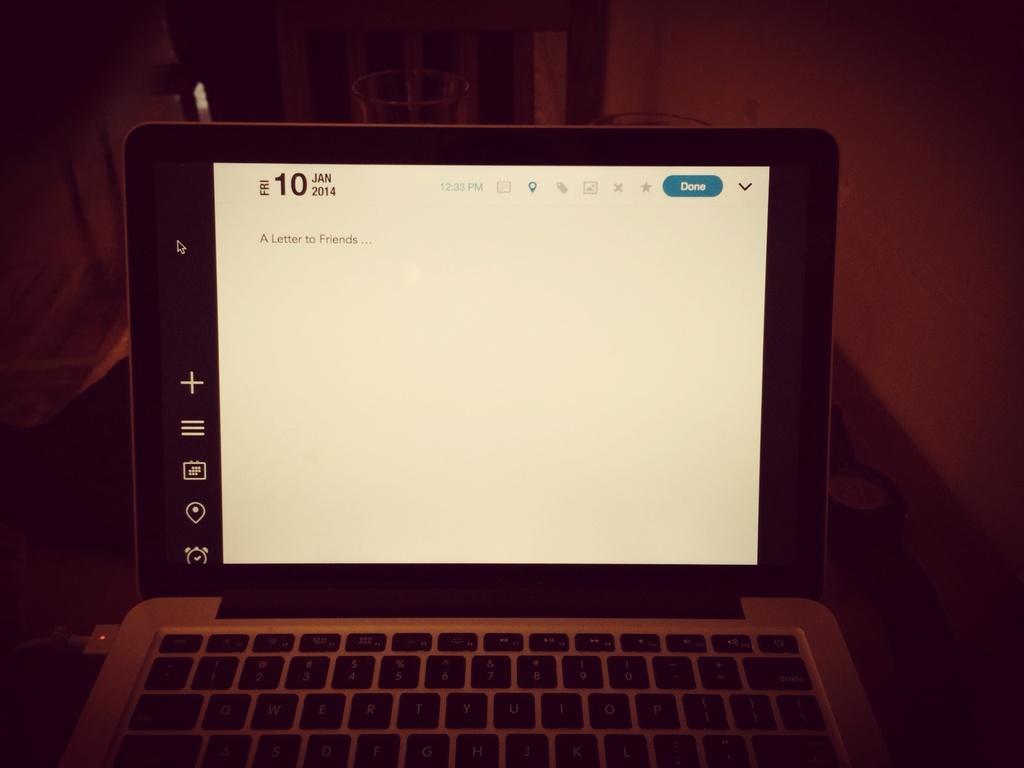What month is it?
Your answer should be very brief. January. 